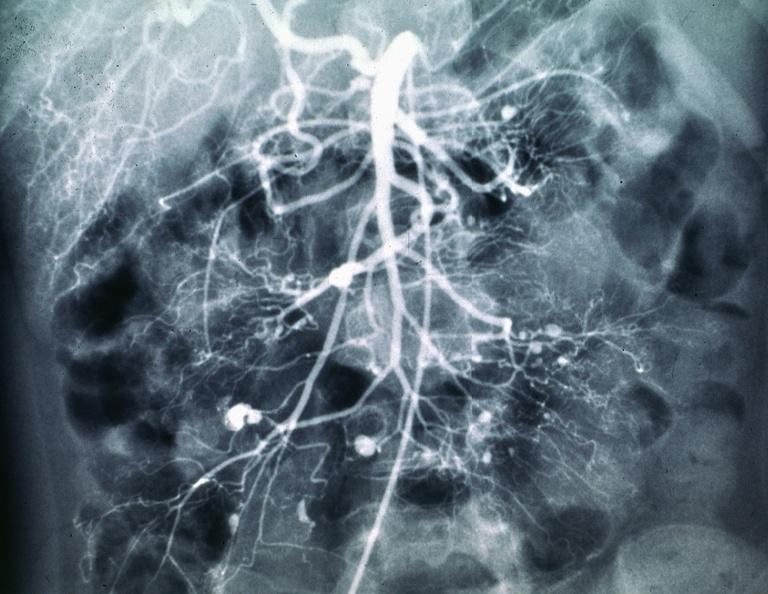does this image show polyarteritis nodosa mesentaric artery arteriogram?
Answer the question using a single word or phrase. Yes 